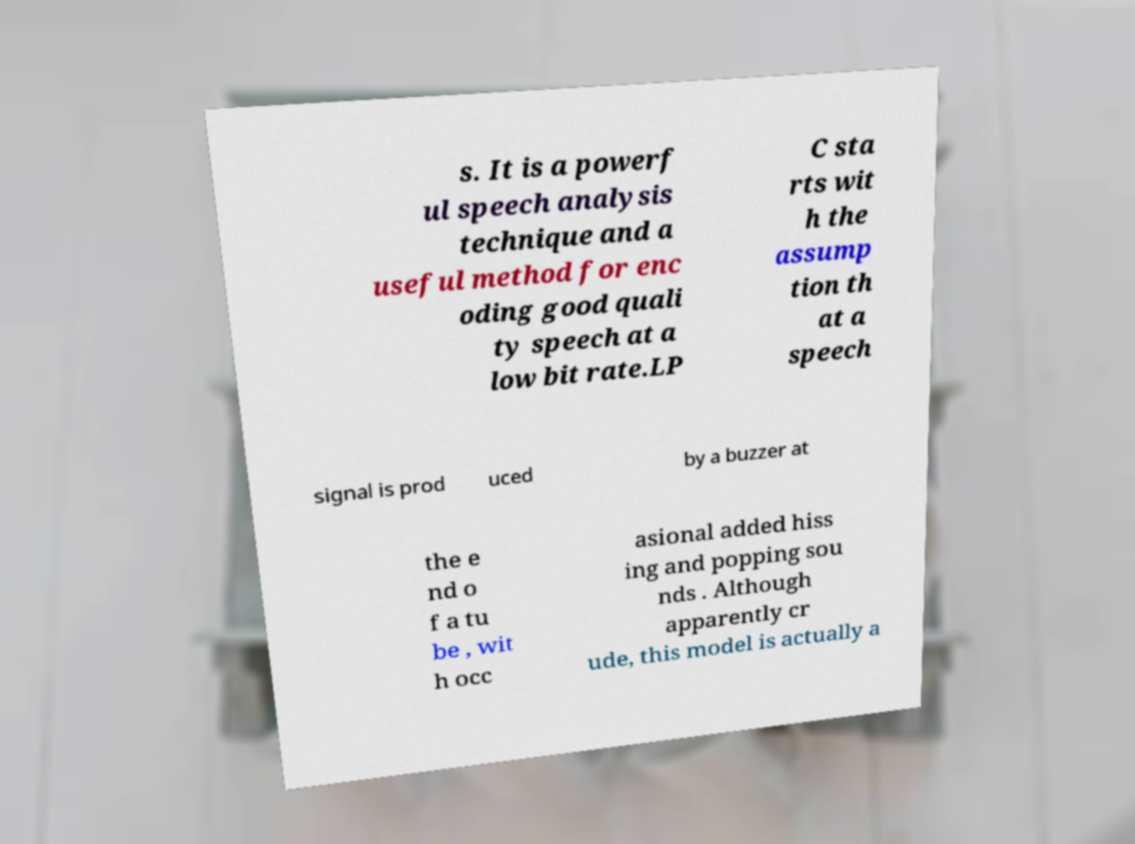Please read and relay the text visible in this image. What does it say? s. It is a powerf ul speech analysis technique and a useful method for enc oding good quali ty speech at a low bit rate.LP C sta rts wit h the assump tion th at a speech signal is prod uced by a buzzer at the e nd o f a tu be , wit h occ asional added hiss ing and popping sou nds . Although apparently cr ude, this model is actually a 